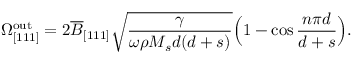Convert formula to latex. <formula><loc_0><loc_0><loc_500><loc_500>\Omega _ { [ 1 1 1 ] } ^ { o u t } = 2 \overline { B } _ { [ 1 1 1 ] } \sqrt { \frac { \gamma } { \omega \rho M _ { s } d ( d + s ) } } \left ( 1 - \cos { \frac { n \pi d } { d + s } } \right ) .</formula> 